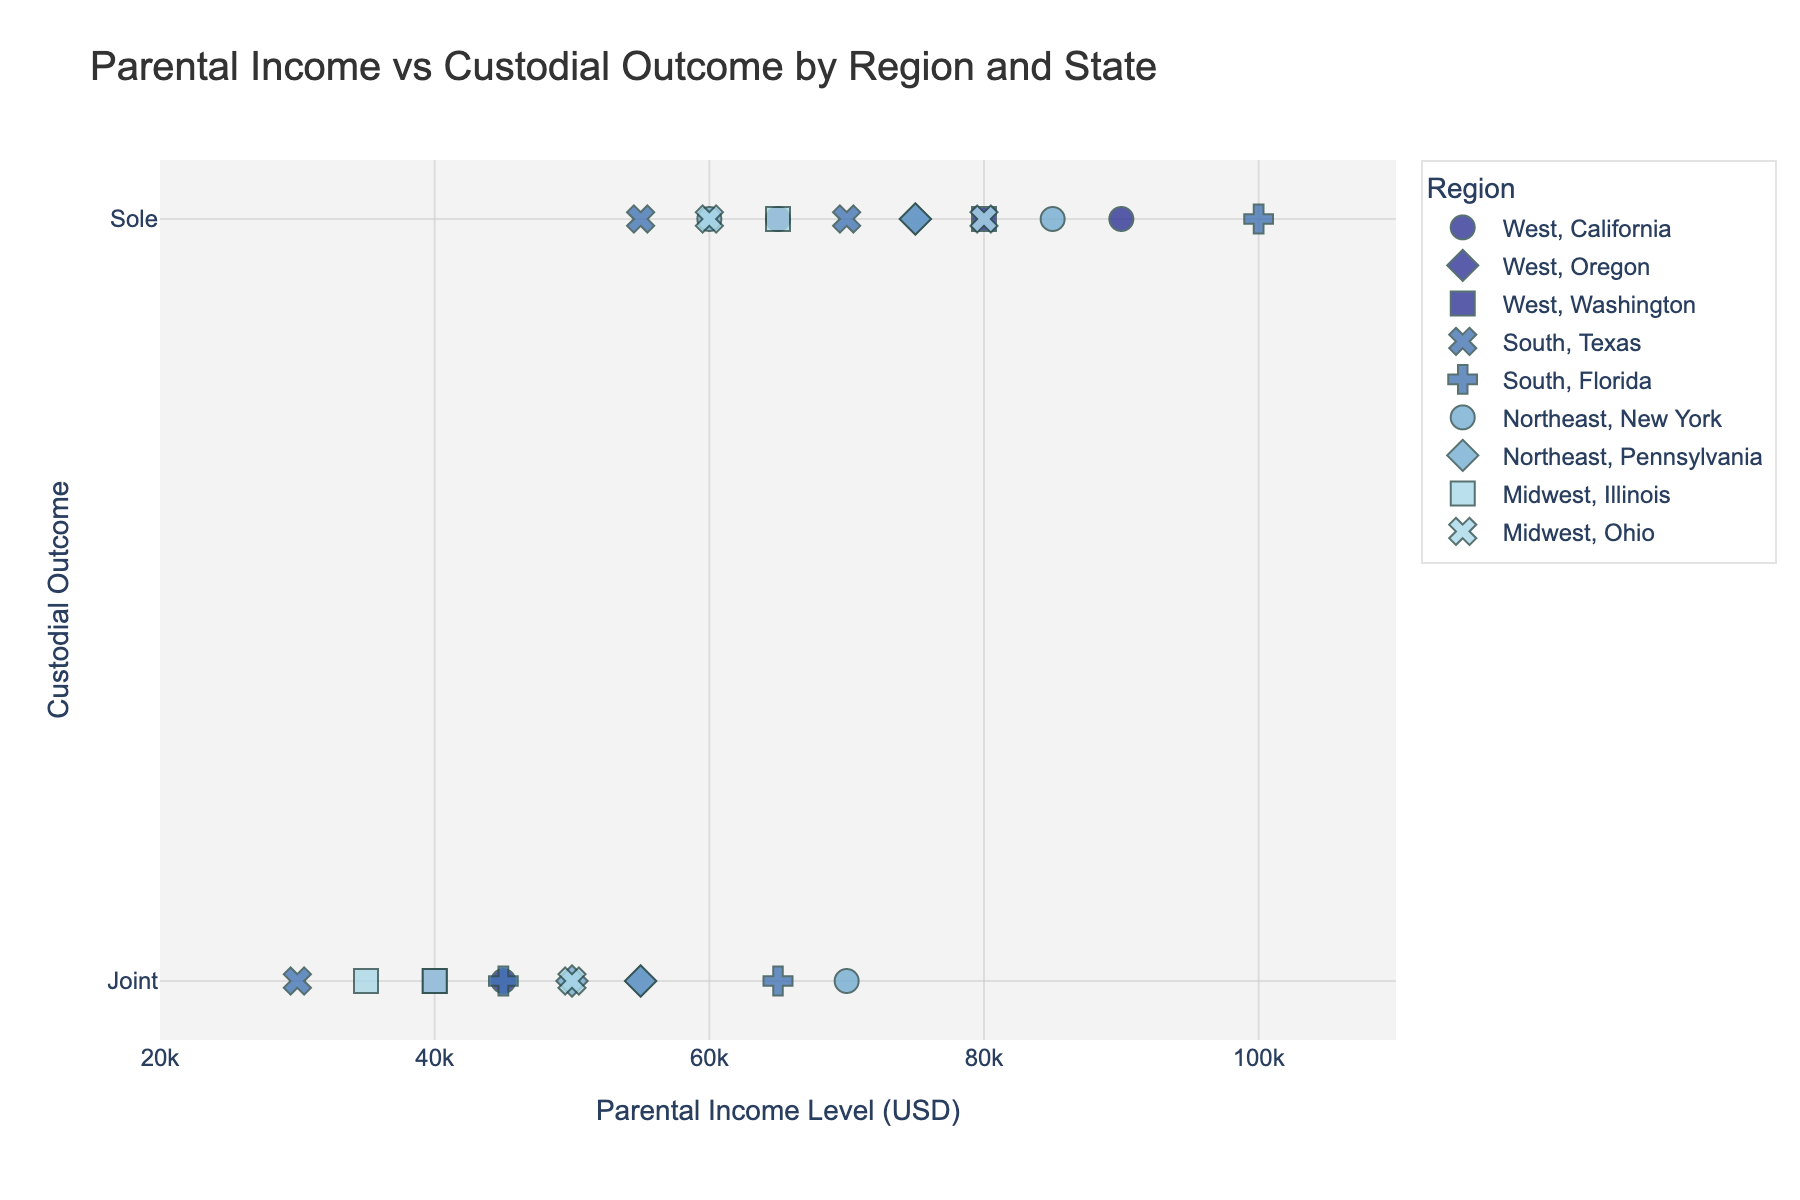What is the title of the figure? The title is usually displayed at the top of the figure and provides a brief description of the plot's content. In this case, the title is described in the code.
Answer: Parental Income vs Custodial Outcome by Region and State Which region has the highest concentration of 'Joint' custodial outcomes? By examining the scatter plot, you can count and compare the instances of 'Joint' custodial outcomes by color, which indicates the region.
Answer: Northeast How many data points represent 'Sole' custodial outcomes in the Midwest? Data points representing the Midwest region, indicated by specific symbols for states in that region, should be counted if they appear in the 'Sole' category on the y-axis.
Answer: 3 What is the median parental income level for 'Sole' custodial outcomes in California? Identify the 'Sole' custodial outcome data points for California within the plot, and find the median value of their income levels. The incomes are 90000 and 65000, so the median is (90000 + 65000) / 2 = 77500.
Answer: 77500 Which state in the West region shows the lowest parental income level for a 'Joint' custodial outcome? Filter out the West region states and identify the 'Joint' custodial outcome data points. Compare their income levels to find the lowest one. Oregon with 55000 is the lowest.
Answer: Oregon Which region has a wider range of parental income levels for 'Sole' custodial outcomes? Inspect the scatter plot and observe the span of income levels in the 'Sole' custodial outcome category for each region by observing the x-axis range.
Answer: South Compare the average parental income level for 'Joint' custodial outcomes in the Northeast and the Midwest. Calculate the mean of parental incomes for 'Joint' outcomes in both regions separately: Midwest = (40000 + 35000 + 50000)/3 = 41667, Northeast = (70000 + 50000 + 55000)/3 = 58333.
Answer: Northeast What is the range of parental income levels for 'Joint' custodial outcomes in Pennsylvania? Identify the 'Joint' custodial outcome points in Pennsylvania and subtract the lowest income from the highest income: 55000 and 50000, range = 55000 - 50000 = 5000.
Answer: 5000 Which region has more data points indicating 'Sole' custodial outcomes, the South or the West? Count the number of 'Sole' custodial outcome data points in both the South and the West regions by looking at the scatter plot symbols and colors.
Answer: South 